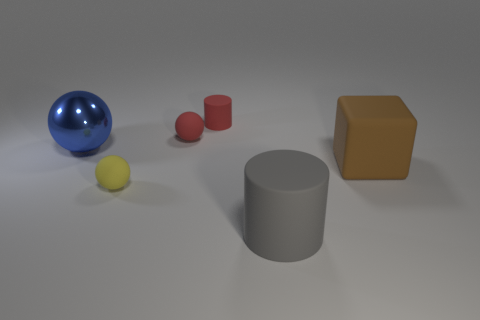Subtract all red spheres. How many spheres are left? 2 Subtract 2 cylinders. How many cylinders are left? 0 Add 1 cyan metallic cylinders. How many objects exist? 7 Subtract all cylinders. How many objects are left? 4 Add 2 yellow matte spheres. How many yellow matte spheres are left? 3 Add 3 small yellow matte objects. How many small yellow matte objects exist? 4 Subtract 1 gray cylinders. How many objects are left? 5 Subtract all gray spheres. Subtract all blue cubes. How many spheres are left? 3 Subtract all brown spheres. Subtract all large gray rubber objects. How many objects are left? 5 